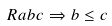<formula> <loc_0><loc_0><loc_500><loc_500>R a b c \Rightarrow b \leq c</formula> 